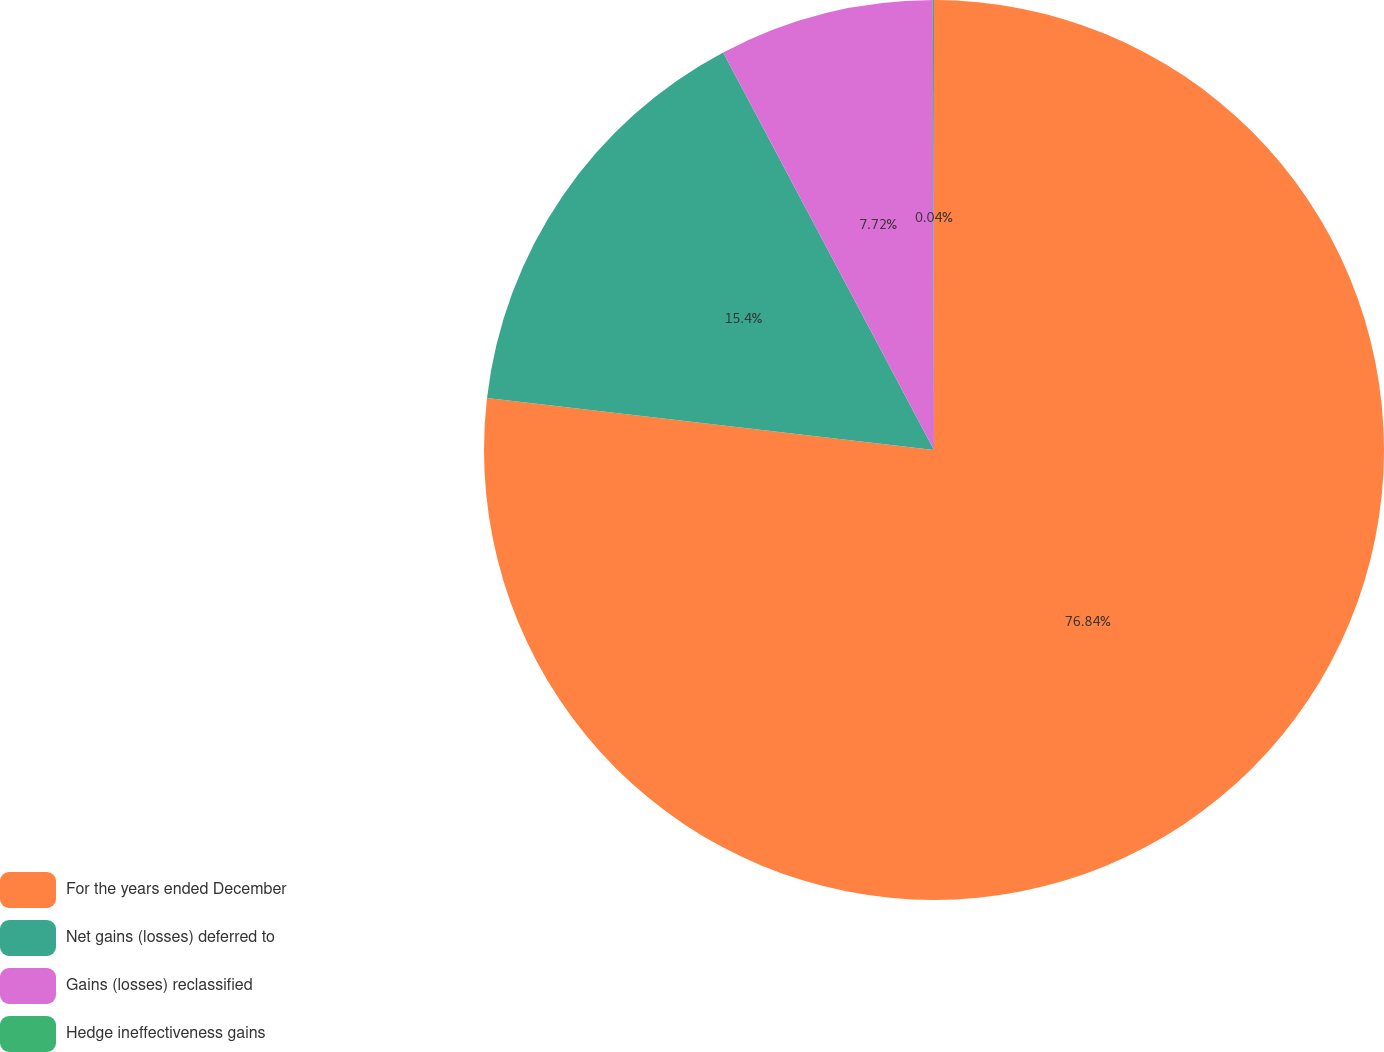<chart> <loc_0><loc_0><loc_500><loc_500><pie_chart><fcel>For the years ended December<fcel>Net gains (losses) deferred to<fcel>Gains (losses) reclassified<fcel>Hedge ineffectiveness gains<nl><fcel>76.84%<fcel>15.4%<fcel>7.72%<fcel>0.04%<nl></chart> 